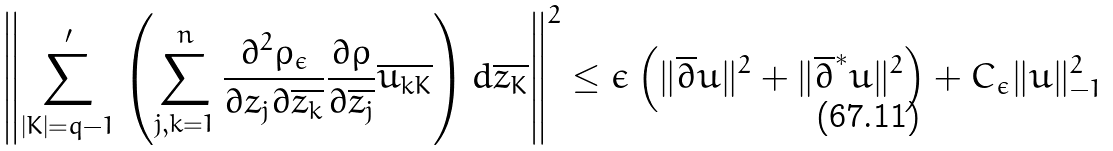<formula> <loc_0><loc_0><loc_500><loc_500>\left \| \sum _ { | K | = q - 1 } ^ { \prime } \left ( \sum _ { j , k = 1 } ^ { n } \frac { \partial ^ { 2 } \rho _ { \epsilon } } { \partial z _ { j } \partial \overline { z _ { k } } } \frac { \partial \rho } { \partial \overline { z _ { j } } } \overline { u _ { k K } } \right ) d \overline { z _ { K } } \right \| ^ { 2 } \leq \epsilon \left ( \| \overline { \partial } u \| ^ { 2 } + \| \overline { \partial } ^ { * } u \| ^ { 2 } \right ) + C _ { \epsilon } \| u \| _ { - 1 } ^ { 2 }</formula> 